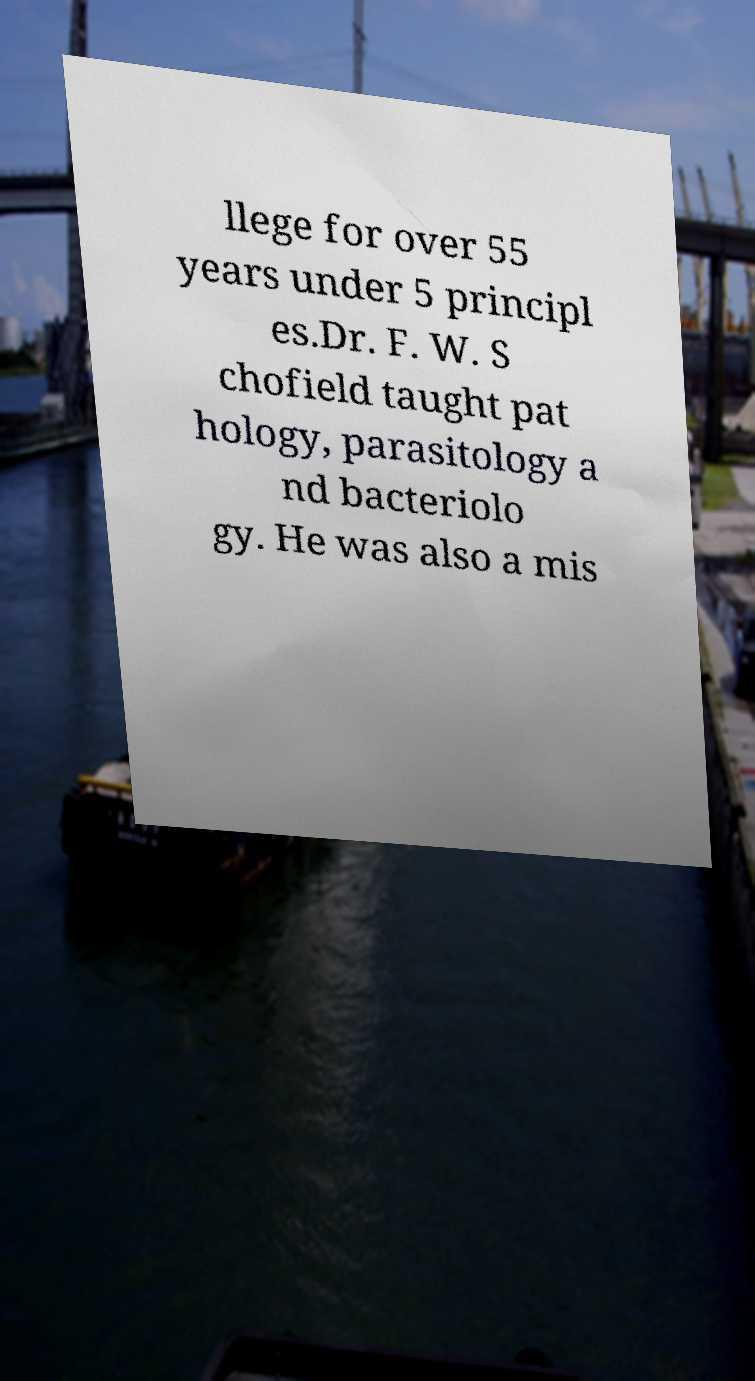What messages or text are displayed in this image? I need them in a readable, typed format. llege for over 55 years under 5 principl es.Dr. F. W. S chofield taught pat hology, parasitology a nd bacteriolo gy. He was also a mis 